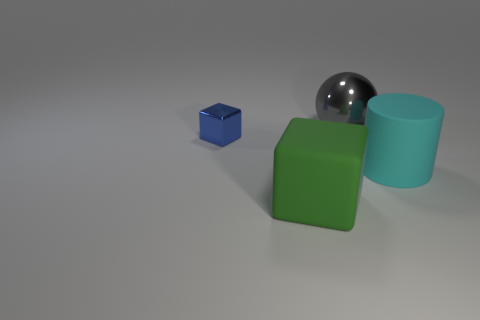Is there anything else that is the same size as the blue cube?
Give a very brief answer. No. Is there anything else that has the same shape as the cyan object?
Offer a very short reply. No. How many shiny objects are either big objects or small blue things?
Ensure brevity in your answer.  2. Is the number of large green rubber objects that are to the right of the large green cube less than the number of green cylinders?
Your response must be concise. No. The thing that is behind the thing left of the rubber object to the left of the cylinder is what shape?
Ensure brevity in your answer.  Sphere. Are there more cyan objects than green metal blocks?
Ensure brevity in your answer.  Yes. How many other things are there of the same material as the large green cube?
Offer a terse response. 1. How many things are either large gray things or metallic things behind the metallic block?
Offer a very short reply. 1. Is the number of big gray balls less than the number of large brown shiny cylinders?
Keep it short and to the point. No. There is a block right of the metallic object in front of the large thing behind the cyan cylinder; what color is it?
Keep it short and to the point. Green. 